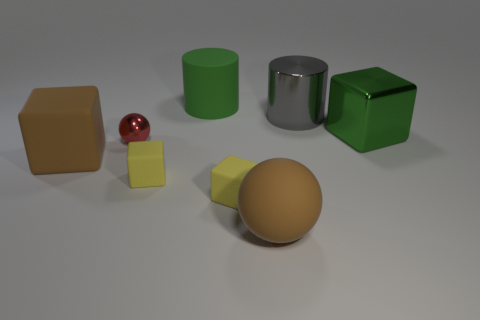What number of things are either green objects on the right side of the rubber cylinder or small brown matte objects?
Provide a succinct answer. 1. The green thing that is the same material as the big gray thing is what shape?
Provide a succinct answer. Cube. There is a gray object; what shape is it?
Provide a short and direct response. Cylinder. What is the color of the object that is behind the big green cube and to the right of the large rubber cylinder?
Ensure brevity in your answer.  Gray. There is a green matte thing that is the same size as the brown cube; what shape is it?
Offer a very short reply. Cylinder. Is there a big metal object of the same shape as the large green matte object?
Provide a succinct answer. Yes. Is the material of the green cube the same as the big cylinder in front of the large green matte thing?
Your answer should be compact. Yes. There is a ball that is in front of the brown thing that is left of the large green object that is left of the metal cube; what is its color?
Ensure brevity in your answer.  Brown. What is the material of the green cylinder that is the same size as the gray metallic cylinder?
Your response must be concise. Rubber. How many green things are the same material as the gray object?
Offer a terse response. 1. 